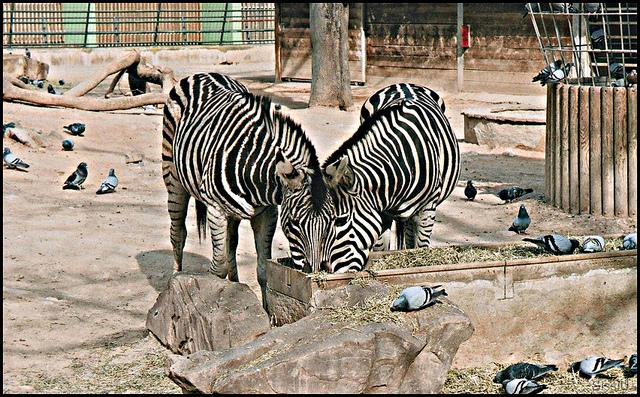How many zebras are eating hay from the trough?

Choices:
A) two
B) three
C) one
D) four two 